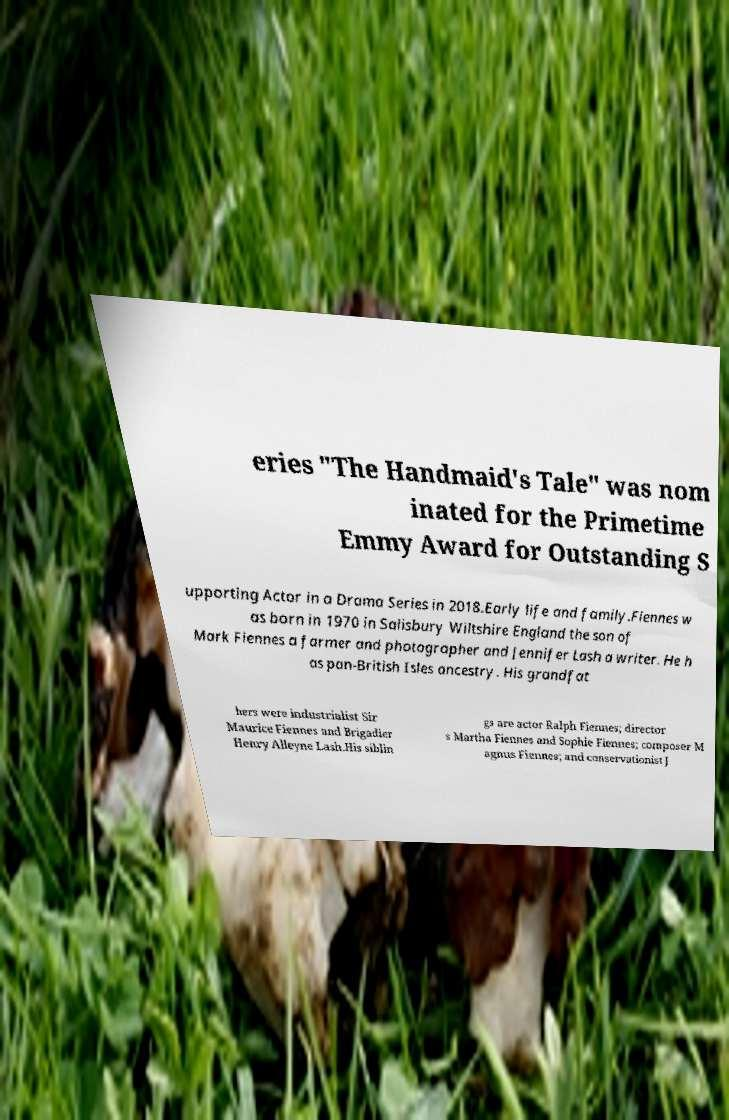Could you extract and type out the text from this image? eries "The Handmaid's Tale" was nom inated for the Primetime Emmy Award for Outstanding S upporting Actor in a Drama Series in 2018.Early life and family.Fiennes w as born in 1970 in Salisbury Wiltshire England the son of Mark Fiennes a farmer and photographer and Jennifer Lash a writer. He h as pan-British Isles ancestry. His grandfat hers were industrialist Sir Maurice Fiennes and Brigadier Henry Alleyne Lash.His siblin gs are actor Ralph Fiennes; director s Martha Fiennes and Sophie Fiennes; composer M agnus Fiennes; and conservationist J 